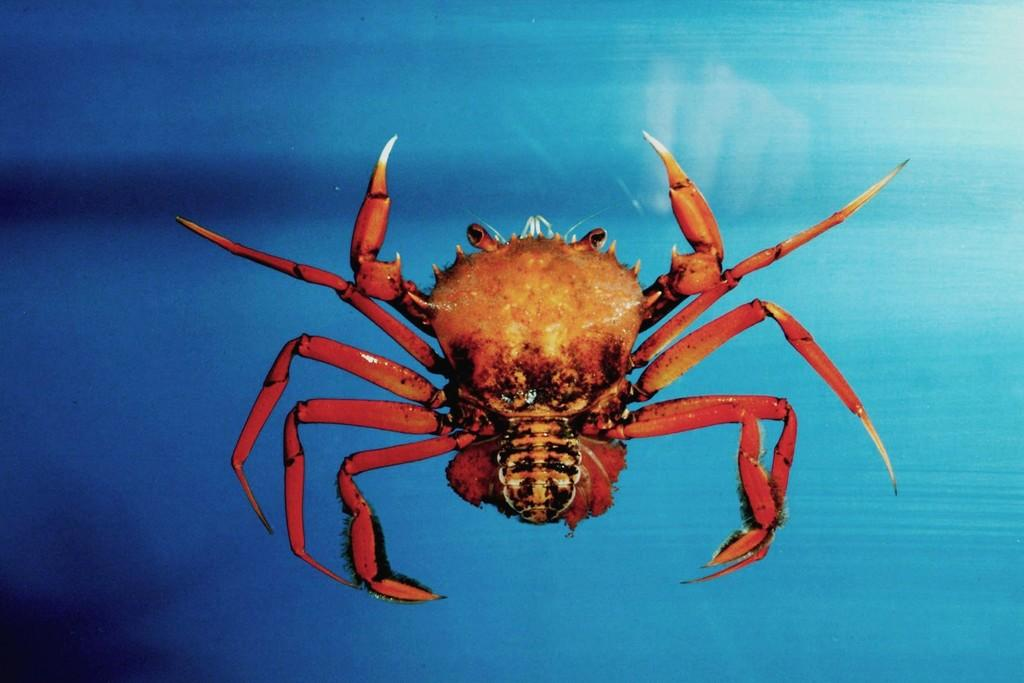What is the main subject in the center of the image? There is an insect in the center of the image. What type of band is playing in the background of the image? There is no band present in the image; it only features an insect in the center. 